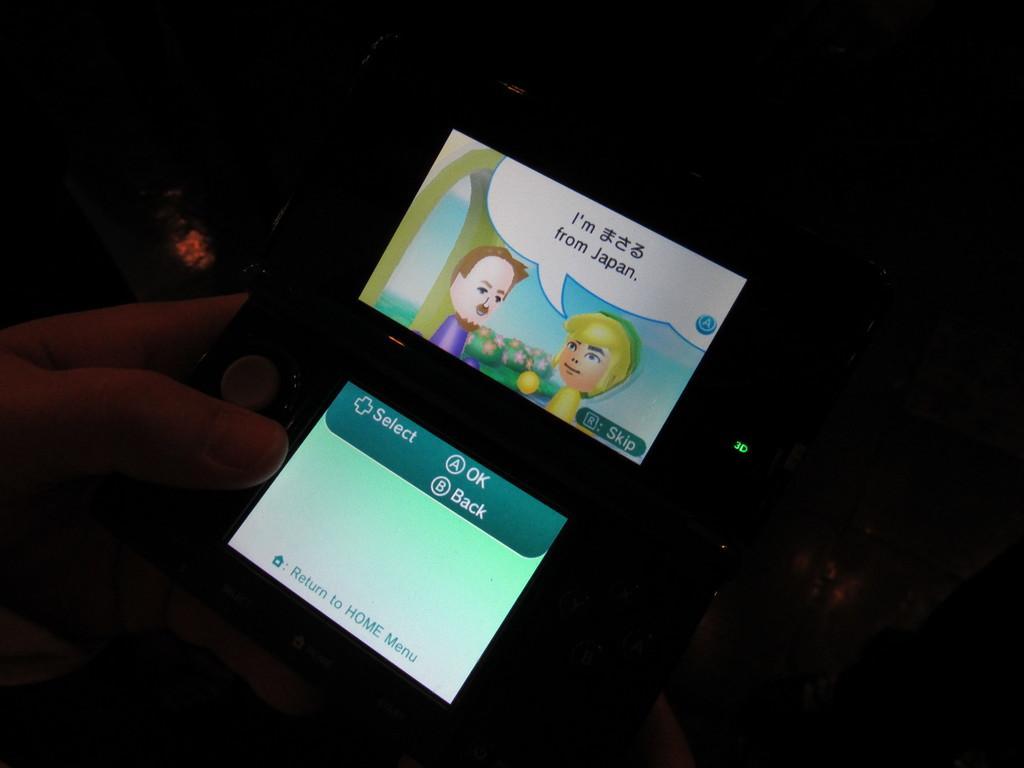Describe this image in one or two sentences. In this image I see a person's hand who is holding an electronic device and I see the screens on it and I see 2 cartoon characters over here and I see something is written on the screens and I see that it is dark in the background. 